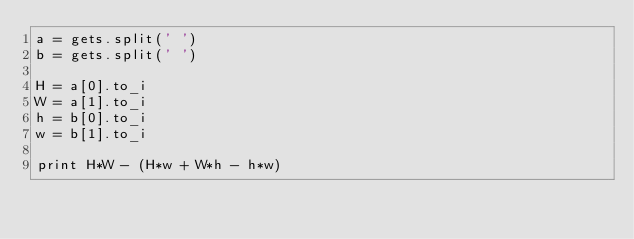<code> <loc_0><loc_0><loc_500><loc_500><_Ruby_>a = gets.split(' ')
b = gets.split(' ')

H = a[0].to_i
W = a[1].to_i
h = b[0].to_i
w = b[1].to_i

print H*W - (H*w + W*h - h*w)</code> 